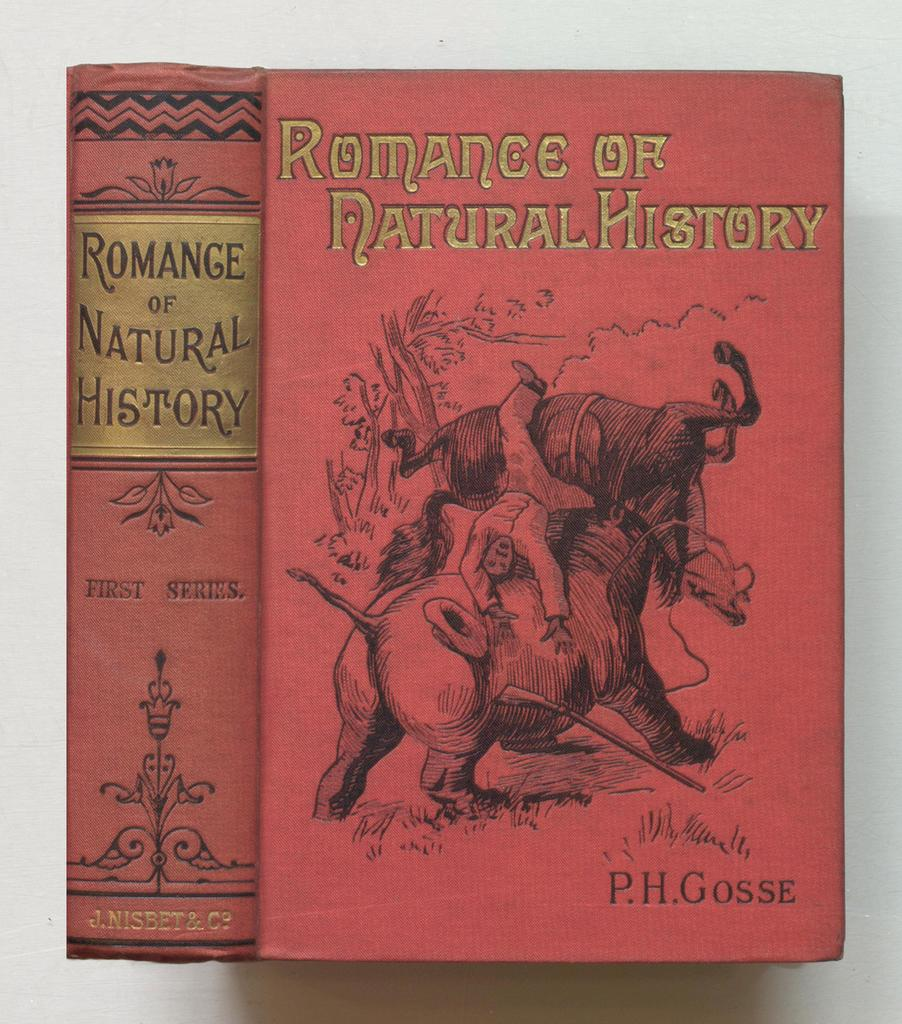<image>
Share a concise interpretation of the image provided. A book by P.H. Gosse has a red cover and the title in gold print. 